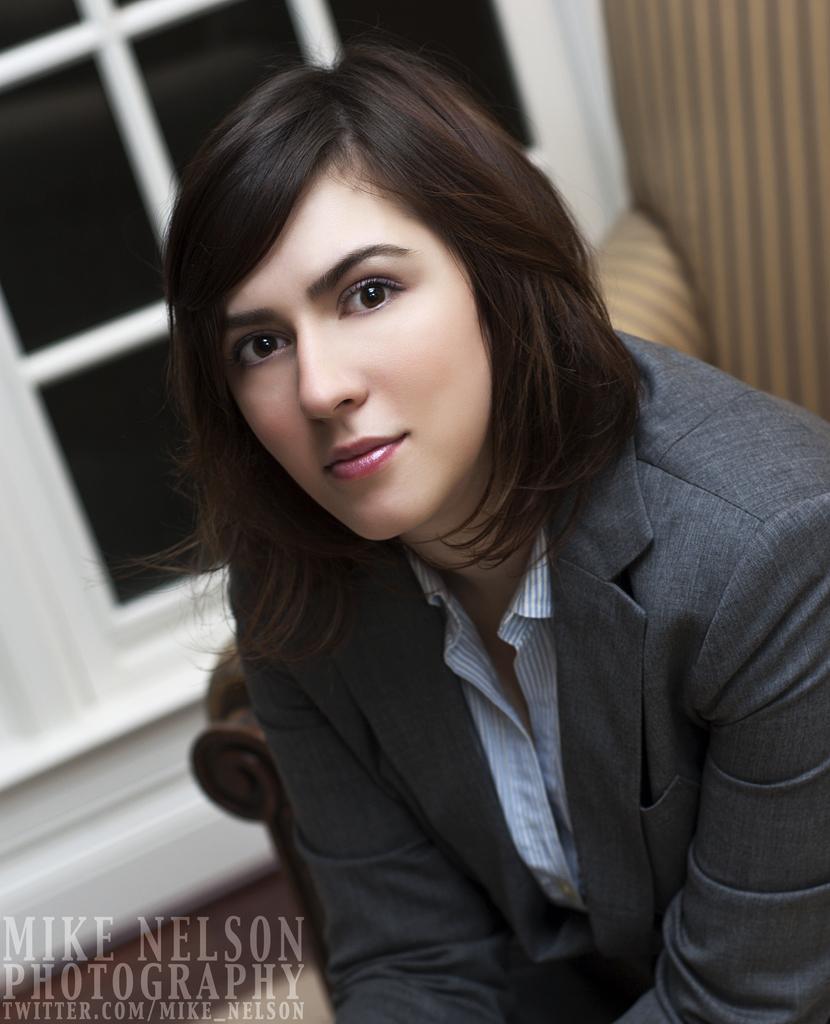Describe this image in one or two sentences. There is a woman. In the back there is a window. Also there is a watermark in the left bottom corner. 